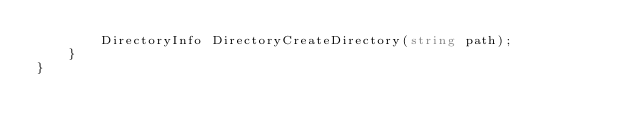Convert code to text. <code><loc_0><loc_0><loc_500><loc_500><_C#_>        DirectoryInfo DirectoryCreateDirectory(string path);
    }
}</code> 